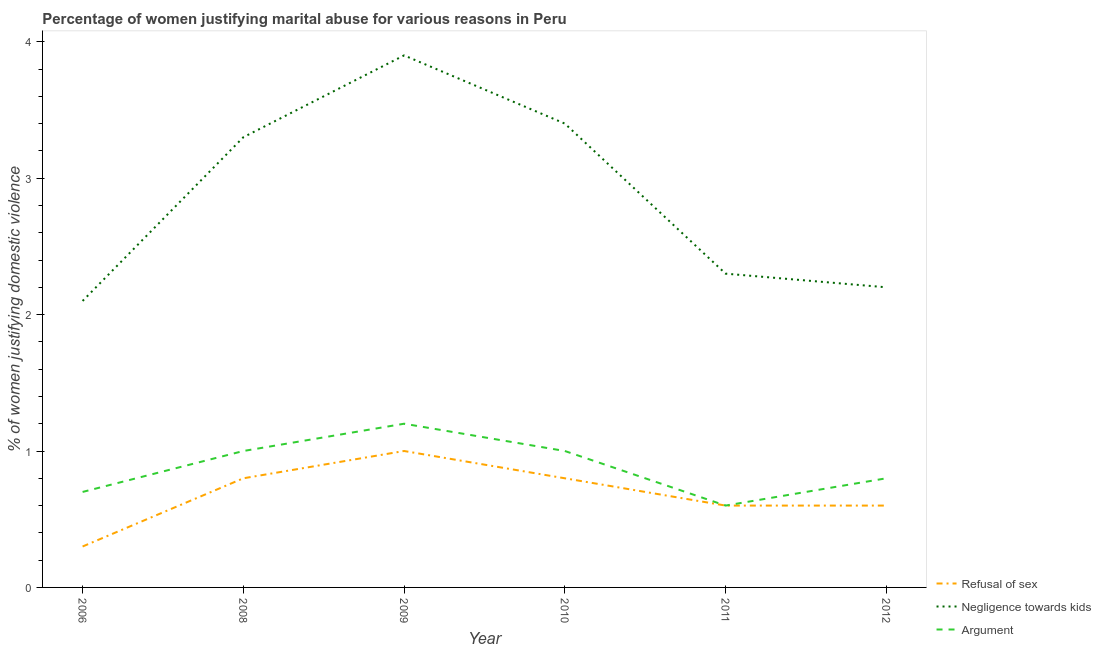How many different coloured lines are there?
Provide a succinct answer. 3. What is the percentage of women justifying domestic violence due to negligence towards kids in 2009?
Provide a succinct answer. 3.9. Across all years, what is the maximum percentage of women justifying domestic violence due to arguments?
Your response must be concise. 1.2. In which year was the percentage of women justifying domestic violence due to arguments maximum?
Ensure brevity in your answer.  2009. What is the difference between the percentage of women justifying domestic violence due to refusal of sex in 2009 and that in 2010?
Your answer should be compact. 0.2. What is the difference between the percentage of women justifying domestic violence due to arguments in 2012 and the percentage of women justifying domestic violence due to negligence towards kids in 2006?
Your answer should be very brief. -1.3. What is the average percentage of women justifying domestic violence due to negligence towards kids per year?
Offer a terse response. 2.87. In the year 2011, what is the difference between the percentage of women justifying domestic violence due to negligence towards kids and percentage of women justifying domestic violence due to arguments?
Give a very brief answer. 1.7. What is the ratio of the percentage of women justifying domestic violence due to refusal of sex in 2008 to that in 2009?
Offer a very short reply. 0.8. Is the percentage of women justifying domestic violence due to negligence towards kids in 2006 less than that in 2008?
Provide a short and direct response. Yes. What is the difference between the highest and the second highest percentage of women justifying domestic violence due to negligence towards kids?
Provide a succinct answer. 0.5. What is the difference between the highest and the lowest percentage of women justifying domestic violence due to negligence towards kids?
Your response must be concise. 1.8. Is the percentage of women justifying domestic violence due to negligence towards kids strictly greater than the percentage of women justifying domestic violence due to arguments over the years?
Your answer should be very brief. Yes. How many lines are there?
Offer a terse response. 3. How many years are there in the graph?
Keep it short and to the point. 6. What is the difference between two consecutive major ticks on the Y-axis?
Offer a terse response. 1. Are the values on the major ticks of Y-axis written in scientific E-notation?
Make the answer very short. No. Does the graph contain any zero values?
Make the answer very short. No. Where does the legend appear in the graph?
Give a very brief answer. Bottom right. How many legend labels are there?
Provide a short and direct response. 3. How are the legend labels stacked?
Provide a short and direct response. Vertical. What is the title of the graph?
Keep it short and to the point. Percentage of women justifying marital abuse for various reasons in Peru. What is the label or title of the Y-axis?
Your answer should be very brief. % of women justifying domestic violence. What is the % of women justifying domestic violence in Refusal of sex in 2006?
Your response must be concise. 0.3. What is the % of women justifying domestic violence in Negligence towards kids in 2006?
Offer a very short reply. 2.1. What is the % of women justifying domestic violence in Argument in 2006?
Provide a short and direct response. 0.7. What is the % of women justifying domestic violence in Negligence towards kids in 2008?
Keep it short and to the point. 3.3. What is the % of women justifying domestic violence of Refusal of sex in 2009?
Give a very brief answer. 1. What is the % of women justifying domestic violence of Refusal of sex in 2010?
Offer a very short reply. 0.8. What is the % of women justifying domestic violence in Refusal of sex in 2011?
Offer a terse response. 0.6. What is the % of women justifying domestic violence in Argument in 2011?
Your answer should be compact. 0.6. What is the % of women justifying domestic violence in Negligence towards kids in 2012?
Offer a very short reply. 2.2. Across all years, what is the maximum % of women justifying domestic violence in Argument?
Provide a short and direct response. 1.2. What is the total % of women justifying domestic violence of Refusal of sex in the graph?
Your response must be concise. 4.1. What is the total % of women justifying domestic violence in Negligence towards kids in the graph?
Give a very brief answer. 17.2. What is the total % of women justifying domestic violence of Argument in the graph?
Provide a succinct answer. 5.3. What is the difference between the % of women justifying domestic violence of Refusal of sex in 2006 and that in 2008?
Give a very brief answer. -0.5. What is the difference between the % of women justifying domestic violence in Negligence towards kids in 2006 and that in 2009?
Provide a short and direct response. -1.8. What is the difference between the % of women justifying domestic violence of Argument in 2006 and that in 2009?
Offer a terse response. -0.5. What is the difference between the % of women justifying domestic violence in Refusal of sex in 2006 and that in 2010?
Offer a very short reply. -0.5. What is the difference between the % of women justifying domestic violence in Negligence towards kids in 2006 and that in 2010?
Provide a short and direct response. -1.3. What is the difference between the % of women justifying domestic violence of Refusal of sex in 2006 and that in 2011?
Provide a short and direct response. -0.3. What is the difference between the % of women justifying domestic violence in Negligence towards kids in 2006 and that in 2011?
Make the answer very short. -0.2. What is the difference between the % of women justifying domestic violence in Negligence towards kids in 2008 and that in 2009?
Provide a succinct answer. -0.6. What is the difference between the % of women justifying domestic violence of Argument in 2008 and that in 2009?
Make the answer very short. -0.2. What is the difference between the % of women justifying domestic violence in Refusal of sex in 2008 and that in 2011?
Offer a terse response. 0.2. What is the difference between the % of women justifying domestic violence in Refusal of sex in 2008 and that in 2012?
Your answer should be very brief. 0.2. What is the difference between the % of women justifying domestic violence in Negligence towards kids in 2009 and that in 2010?
Your answer should be compact. 0.5. What is the difference between the % of women justifying domestic violence in Argument in 2009 and that in 2010?
Ensure brevity in your answer.  0.2. What is the difference between the % of women justifying domestic violence of Refusal of sex in 2009 and that in 2011?
Your response must be concise. 0.4. What is the difference between the % of women justifying domestic violence in Refusal of sex in 2009 and that in 2012?
Offer a terse response. 0.4. What is the difference between the % of women justifying domestic violence of Negligence towards kids in 2010 and that in 2011?
Provide a succinct answer. 1.1. What is the difference between the % of women justifying domestic violence of Argument in 2010 and that in 2011?
Your answer should be very brief. 0.4. What is the difference between the % of women justifying domestic violence of Refusal of sex in 2010 and that in 2012?
Give a very brief answer. 0.2. What is the difference between the % of women justifying domestic violence of Negligence towards kids in 2010 and that in 2012?
Keep it short and to the point. 1.2. What is the difference between the % of women justifying domestic violence of Argument in 2010 and that in 2012?
Your answer should be very brief. 0.2. What is the difference between the % of women justifying domestic violence of Refusal of sex in 2011 and that in 2012?
Offer a terse response. 0. What is the difference between the % of women justifying domestic violence in Refusal of sex in 2006 and the % of women justifying domestic violence in Negligence towards kids in 2008?
Provide a succinct answer. -3. What is the difference between the % of women justifying domestic violence in Refusal of sex in 2006 and the % of women justifying domestic violence in Argument in 2008?
Provide a succinct answer. -0.7. What is the difference between the % of women justifying domestic violence in Refusal of sex in 2006 and the % of women justifying domestic violence in Argument in 2009?
Offer a terse response. -0.9. What is the difference between the % of women justifying domestic violence in Negligence towards kids in 2006 and the % of women justifying domestic violence in Argument in 2009?
Give a very brief answer. 0.9. What is the difference between the % of women justifying domestic violence of Refusal of sex in 2006 and the % of women justifying domestic violence of Negligence towards kids in 2010?
Ensure brevity in your answer.  -3.1. What is the difference between the % of women justifying domestic violence of Refusal of sex in 2006 and the % of women justifying domestic violence of Argument in 2010?
Provide a short and direct response. -0.7. What is the difference between the % of women justifying domestic violence of Negligence towards kids in 2006 and the % of women justifying domestic violence of Argument in 2010?
Your answer should be very brief. 1.1. What is the difference between the % of women justifying domestic violence in Negligence towards kids in 2006 and the % of women justifying domestic violence in Argument in 2012?
Provide a short and direct response. 1.3. What is the difference between the % of women justifying domestic violence in Refusal of sex in 2008 and the % of women justifying domestic violence in Argument in 2009?
Ensure brevity in your answer.  -0.4. What is the difference between the % of women justifying domestic violence of Negligence towards kids in 2008 and the % of women justifying domestic violence of Argument in 2009?
Offer a very short reply. 2.1. What is the difference between the % of women justifying domestic violence of Refusal of sex in 2008 and the % of women justifying domestic violence of Negligence towards kids in 2010?
Give a very brief answer. -2.6. What is the difference between the % of women justifying domestic violence in Refusal of sex in 2008 and the % of women justifying domestic violence in Argument in 2010?
Offer a terse response. -0.2. What is the difference between the % of women justifying domestic violence in Refusal of sex in 2008 and the % of women justifying domestic violence in Argument in 2011?
Your answer should be compact. 0.2. What is the difference between the % of women justifying domestic violence of Negligence towards kids in 2008 and the % of women justifying domestic violence of Argument in 2011?
Provide a short and direct response. 2.7. What is the difference between the % of women justifying domestic violence of Negligence towards kids in 2008 and the % of women justifying domestic violence of Argument in 2012?
Your answer should be compact. 2.5. What is the difference between the % of women justifying domestic violence in Refusal of sex in 2009 and the % of women justifying domestic violence in Negligence towards kids in 2010?
Keep it short and to the point. -2.4. What is the difference between the % of women justifying domestic violence in Negligence towards kids in 2009 and the % of women justifying domestic violence in Argument in 2010?
Provide a short and direct response. 2.9. What is the difference between the % of women justifying domestic violence of Refusal of sex in 2009 and the % of women justifying domestic violence of Negligence towards kids in 2011?
Give a very brief answer. -1.3. What is the difference between the % of women justifying domestic violence of Negligence towards kids in 2009 and the % of women justifying domestic violence of Argument in 2011?
Offer a terse response. 3.3. What is the difference between the % of women justifying domestic violence of Refusal of sex in 2009 and the % of women justifying domestic violence of Argument in 2012?
Make the answer very short. 0.2. What is the difference between the % of women justifying domestic violence in Negligence towards kids in 2009 and the % of women justifying domestic violence in Argument in 2012?
Provide a short and direct response. 3.1. What is the difference between the % of women justifying domestic violence in Refusal of sex in 2010 and the % of women justifying domestic violence in Argument in 2011?
Give a very brief answer. 0.2. What is the difference between the % of women justifying domestic violence of Refusal of sex in 2010 and the % of women justifying domestic violence of Argument in 2012?
Keep it short and to the point. 0. What is the difference between the % of women justifying domestic violence of Negligence towards kids in 2010 and the % of women justifying domestic violence of Argument in 2012?
Your response must be concise. 2.6. What is the difference between the % of women justifying domestic violence of Refusal of sex in 2011 and the % of women justifying domestic violence of Argument in 2012?
Make the answer very short. -0.2. What is the difference between the % of women justifying domestic violence of Negligence towards kids in 2011 and the % of women justifying domestic violence of Argument in 2012?
Provide a succinct answer. 1.5. What is the average % of women justifying domestic violence of Refusal of sex per year?
Provide a short and direct response. 0.68. What is the average % of women justifying domestic violence of Negligence towards kids per year?
Your response must be concise. 2.87. What is the average % of women justifying domestic violence of Argument per year?
Your answer should be compact. 0.88. In the year 2006, what is the difference between the % of women justifying domestic violence in Refusal of sex and % of women justifying domestic violence in Argument?
Provide a short and direct response. -0.4. In the year 2008, what is the difference between the % of women justifying domestic violence of Refusal of sex and % of women justifying domestic violence of Negligence towards kids?
Your response must be concise. -2.5. In the year 2008, what is the difference between the % of women justifying domestic violence of Refusal of sex and % of women justifying domestic violence of Argument?
Keep it short and to the point. -0.2. In the year 2009, what is the difference between the % of women justifying domestic violence of Refusal of sex and % of women justifying domestic violence of Negligence towards kids?
Your response must be concise. -2.9. In the year 2009, what is the difference between the % of women justifying domestic violence of Refusal of sex and % of women justifying domestic violence of Argument?
Offer a very short reply. -0.2. In the year 2009, what is the difference between the % of women justifying domestic violence of Negligence towards kids and % of women justifying domestic violence of Argument?
Keep it short and to the point. 2.7. In the year 2010, what is the difference between the % of women justifying domestic violence in Refusal of sex and % of women justifying domestic violence in Negligence towards kids?
Provide a succinct answer. -2.6. In the year 2010, what is the difference between the % of women justifying domestic violence of Negligence towards kids and % of women justifying domestic violence of Argument?
Offer a terse response. 2.4. In the year 2011, what is the difference between the % of women justifying domestic violence of Refusal of sex and % of women justifying domestic violence of Negligence towards kids?
Make the answer very short. -1.7. In the year 2011, what is the difference between the % of women justifying domestic violence of Refusal of sex and % of women justifying domestic violence of Argument?
Ensure brevity in your answer.  0. In the year 2011, what is the difference between the % of women justifying domestic violence in Negligence towards kids and % of women justifying domestic violence in Argument?
Offer a terse response. 1.7. What is the ratio of the % of women justifying domestic violence of Negligence towards kids in 2006 to that in 2008?
Provide a succinct answer. 0.64. What is the ratio of the % of women justifying domestic violence in Argument in 2006 to that in 2008?
Make the answer very short. 0.7. What is the ratio of the % of women justifying domestic violence in Refusal of sex in 2006 to that in 2009?
Your answer should be very brief. 0.3. What is the ratio of the % of women justifying domestic violence in Negligence towards kids in 2006 to that in 2009?
Your answer should be compact. 0.54. What is the ratio of the % of women justifying domestic violence of Argument in 2006 to that in 2009?
Give a very brief answer. 0.58. What is the ratio of the % of women justifying domestic violence of Negligence towards kids in 2006 to that in 2010?
Keep it short and to the point. 0.62. What is the ratio of the % of women justifying domestic violence in Refusal of sex in 2006 to that in 2011?
Ensure brevity in your answer.  0.5. What is the ratio of the % of women justifying domestic violence of Negligence towards kids in 2006 to that in 2011?
Keep it short and to the point. 0.91. What is the ratio of the % of women justifying domestic violence in Refusal of sex in 2006 to that in 2012?
Your answer should be very brief. 0.5. What is the ratio of the % of women justifying domestic violence in Negligence towards kids in 2006 to that in 2012?
Keep it short and to the point. 0.95. What is the ratio of the % of women justifying domestic violence in Argument in 2006 to that in 2012?
Give a very brief answer. 0.88. What is the ratio of the % of women justifying domestic violence in Refusal of sex in 2008 to that in 2009?
Keep it short and to the point. 0.8. What is the ratio of the % of women justifying domestic violence of Negligence towards kids in 2008 to that in 2009?
Provide a short and direct response. 0.85. What is the ratio of the % of women justifying domestic violence in Negligence towards kids in 2008 to that in 2010?
Offer a terse response. 0.97. What is the ratio of the % of women justifying domestic violence of Refusal of sex in 2008 to that in 2011?
Provide a short and direct response. 1.33. What is the ratio of the % of women justifying domestic violence in Negligence towards kids in 2008 to that in 2011?
Offer a very short reply. 1.43. What is the ratio of the % of women justifying domestic violence in Negligence towards kids in 2008 to that in 2012?
Provide a succinct answer. 1.5. What is the ratio of the % of women justifying domestic violence of Argument in 2008 to that in 2012?
Give a very brief answer. 1.25. What is the ratio of the % of women justifying domestic violence of Refusal of sex in 2009 to that in 2010?
Give a very brief answer. 1.25. What is the ratio of the % of women justifying domestic violence in Negligence towards kids in 2009 to that in 2010?
Your answer should be compact. 1.15. What is the ratio of the % of women justifying domestic violence in Argument in 2009 to that in 2010?
Your answer should be compact. 1.2. What is the ratio of the % of women justifying domestic violence in Refusal of sex in 2009 to that in 2011?
Your response must be concise. 1.67. What is the ratio of the % of women justifying domestic violence of Negligence towards kids in 2009 to that in 2011?
Ensure brevity in your answer.  1.7. What is the ratio of the % of women justifying domestic violence of Refusal of sex in 2009 to that in 2012?
Your answer should be very brief. 1.67. What is the ratio of the % of women justifying domestic violence of Negligence towards kids in 2009 to that in 2012?
Your answer should be very brief. 1.77. What is the ratio of the % of women justifying domestic violence in Negligence towards kids in 2010 to that in 2011?
Offer a very short reply. 1.48. What is the ratio of the % of women justifying domestic violence of Negligence towards kids in 2010 to that in 2012?
Your answer should be very brief. 1.55. What is the ratio of the % of women justifying domestic violence of Argument in 2010 to that in 2012?
Make the answer very short. 1.25. What is the ratio of the % of women justifying domestic violence in Refusal of sex in 2011 to that in 2012?
Make the answer very short. 1. What is the ratio of the % of women justifying domestic violence of Negligence towards kids in 2011 to that in 2012?
Provide a short and direct response. 1.05. What is the ratio of the % of women justifying domestic violence in Argument in 2011 to that in 2012?
Provide a short and direct response. 0.75. What is the difference between the highest and the second highest % of women justifying domestic violence of Negligence towards kids?
Offer a terse response. 0.5. What is the difference between the highest and the lowest % of women justifying domestic violence of Refusal of sex?
Provide a short and direct response. 0.7. What is the difference between the highest and the lowest % of women justifying domestic violence in Negligence towards kids?
Provide a short and direct response. 1.8. What is the difference between the highest and the lowest % of women justifying domestic violence in Argument?
Ensure brevity in your answer.  0.6. 